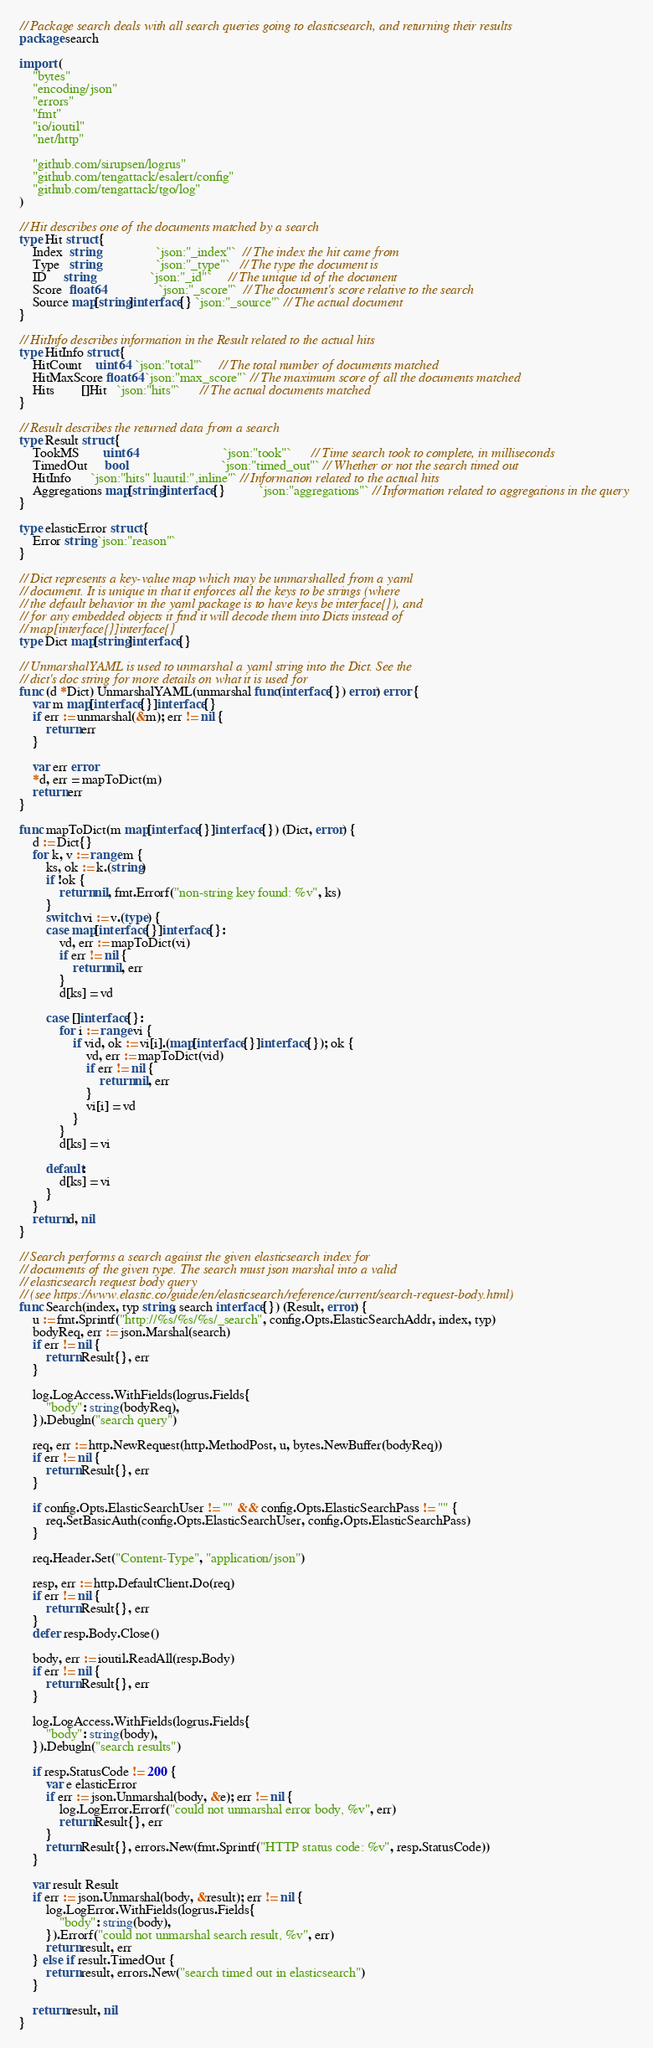<code> <loc_0><loc_0><loc_500><loc_500><_Go_>// Package search deals with all search queries going to elasticsearch, and returning their results
package search

import (
	"bytes"
	"encoding/json"
	"errors"
	"fmt"
	"io/ioutil"
	"net/http"

	"github.com/sirupsen/logrus"
	"github.com/tengattack/esalert/config"
	"github.com/tengattack/tgo/log"
)

// Hit describes one of the documents matched by a search
type Hit struct {
	Index  string                 `json:"_index"`  // The index the hit came from
	Type   string                 `json:"_type"`   // The type the document is
	ID     string                 `json:"_id"`     // The unique id of the document
	Score  float64                `json:"_score"`  // The document's score relative to the search
	Source map[string]interface{} `json:"_source"` // The actual document
}

// HitInfo describes information in the Result related to the actual hits
type HitInfo struct {
	HitCount    uint64  `json:"total"`     // The total number of documents matched
	HitMaxScore float64 `json:"max_score"` // The maximum score of all the documents matched
	Hits        []Hit   `json:"hits"`      // The actual documents matched
}

// Result describes the returned data from a search
type Result struct {
	TookMS       uint64                          `json:"took"`      // Time search took to complete, in milliseconds
	TimedOut     bool                            `json:"timed_out"` // Whether or not the search timed out
	HitInfo      `json:"hits" luautil:",inline"` // Information related to the actual hits
	Aggregations map[string]interface{}          `json:"aggregations"` // Information related to aggregations in the query
}

type elasticError struct {
	Error string `json:"reason"`
}

// Dict represents a key-value map which may be unmarshalled from a yaml
// document. It is unique in that it enforces all the keys to be strings (where
// the default behavior in the yaml package is to have keys be interface{}), and
// for any embedded objects it find it will decode them into Dicts instead of
// map[interface{}]interface{}
type Dict map[string]interface{}

// UnmarshalYAML is used to unmarshal a yaml string into the Dict. See the
// dict's doc string for more details on what it is used for
func (d *Dict) UnmarshalYAML(unmarshal func(interface{}) error) error {
	var m map[interface{}]interface{}
	if err := unmarshal(&m); err != nil {
		return err
	}

	var err error
	*d, err = mapToDict(m)
	return err
}

func mapToDict(m map[interface{}]interface{}) (Dict, error) {
	d := Dict{}
	for k, v := range m {
		ks, ok := k.(string)
		if !ok {
			return nil, fmt.Errorf("non-string key found: %v", ks)
		}
		switch vi := v.(type) {
		case map[interface{}]interface{}:
			vd, err := mapToDict(vi)
			if err != nil {
				return nil, err
			}
			d[ks] = vd

		case []interface{}:
			for i := range vi {
				if vid, ok := vi[i].(map[interface{}]interface{}); ok {
					vd, err := mapToDict(vid)
					if err != nil {
						return nil, err
					}
					vi[i] = vd
				}
			}
			d[ks] = vi

		default:
			d[ks] = vi
		}
	}
	return d, nil
}

// Search performs a search against the given elasticsearch index for
// documents of the given type. The search must json marshal into a valid
// elasticsearch request body query
// (see https://www.elastic.co/guide/en/elasticsearch/reference/current/search-request-body.html)
func Search(index, typ string, search interface{}) (Result, error) {
	u := fmt.Sprintf("http://%s/%s/%s/_search", config.Opts.ElasticSearchAddr, index, typ)
	bodyReq, err := json.Marshal(search)
	if err != nil {
		return Result{}, err
	}

	log.LogAccess.WithFields(logrus.Fields{
		"body": string(bodyReq),
	}).Debugln("search query")

	req, err := http.NewRequest(http.MethodPost, u, bytes.NewBuffer(bodyReq))
	if err != nil {
		return Result{}, err
	}

	if config.Opts.ElasticSearchUser != "" && config.Opts.ElasticSearchPass != "" {
		req.SetBasicAuth(config.Opts.ElasticSearchUser, config.Opts.ElasticSearchPass)
	}

	req.Header.Set("Content-Type", "application/json")

	resp, err := http.DefaultClient.Do(req)
	if err != nil {
		return Result{}, err
	}
	defer resp.Body.Close()

	body, err := ioutil.ReadAll(resp.Body)
	if err != nil {
		return Result{}, err
	}

	log.LogAccess.WithFields(logrus.Fields{
		"body": string(body),
	}).Debugln("search results")

	if resp.StatusCode != 200 {
		var e elasticError
		if err := json.Unmarshal(body, &e); err != nil {
			log.LogError.Errorf("could not unmarshal error body, %v", err)
			return Result{}, err
		}
		return Result{}, errors.New(fmt.Sprintf("HTTP status code: %v", resp.StatusCode))
	}

	var result Result
	if err := json.Unmarshal(body, &result); err != nil {
		log.LogError.WithFields(logrus.Fields{
			"body": string(body),
		}).Errorf("could not unmarshal search result, %v", err)
		return result, err
	} else if result.TimedOut {
		return result, errors.New("search timed out in elasticsearch")
	}

	return result, nil
}
</code> 